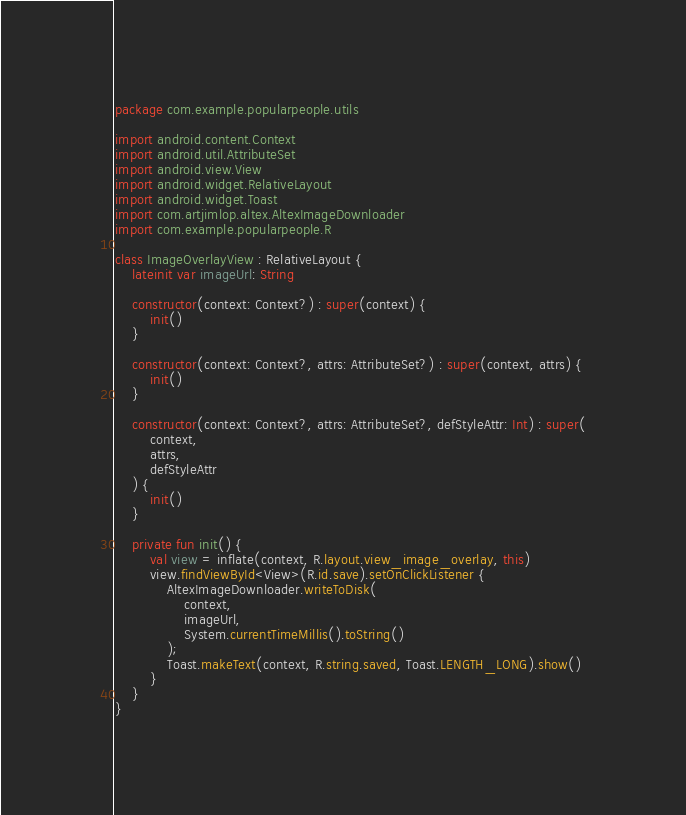Convert code to text. <code><loc_0><loc_0><loc_500><loc_500><_Kotlin_>package com.example.popularpeople.utils

import android.content.Context
import android.util.AttributeSet
import android.view.View
import android.widget.RelativeLayout
import android.widget.Toast
import com.artjimlop.altex.AltexImageDownloader
import com.example.popularpeople.R

class ImageOverlayView : RelativeLayout {
    lateinit var imageUrl: String

    constructor(context: Context?) : super(context) {
        init()
    }

    constructor(context: Context?, attrs: AttributeSet?) : super(context, attrs) {
        init()
    }

    constructor(context: Context?, attrs: AttributeSet?, defStyleAttr: Int) : super(
        context,
        attrs,
        defStyleAttr
    ) {
        init()
    }

    private fun init() {
        val view = inflate(context, R.layout.view_image_overlay, this)
        view.findViewById<View>(R.id.save).setOnClickListener {
            AltexImageDownloader.writeToDisk(
                context,
                imageUrl,
                System.currentTimeMillis().toString()
            );
            Toast.makeText(context, R.string.saved, Toast.LENGTH_LONG).show()
        }
    }
}</code> 